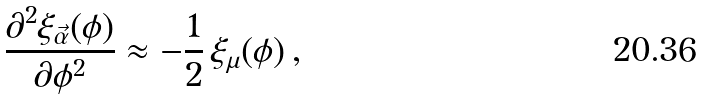<formula> <loc_0><loc_0><loc_500><loc_500>\frac { \partial ^ { 2 } \xi _ { \vec { \alpha } } ( \phi ) } { \partial \phi ^ { 2 } } \approx - \frac { 1 } { 2 } \, \xi _ { \mu } ( \phi ) \, ,</formula> 